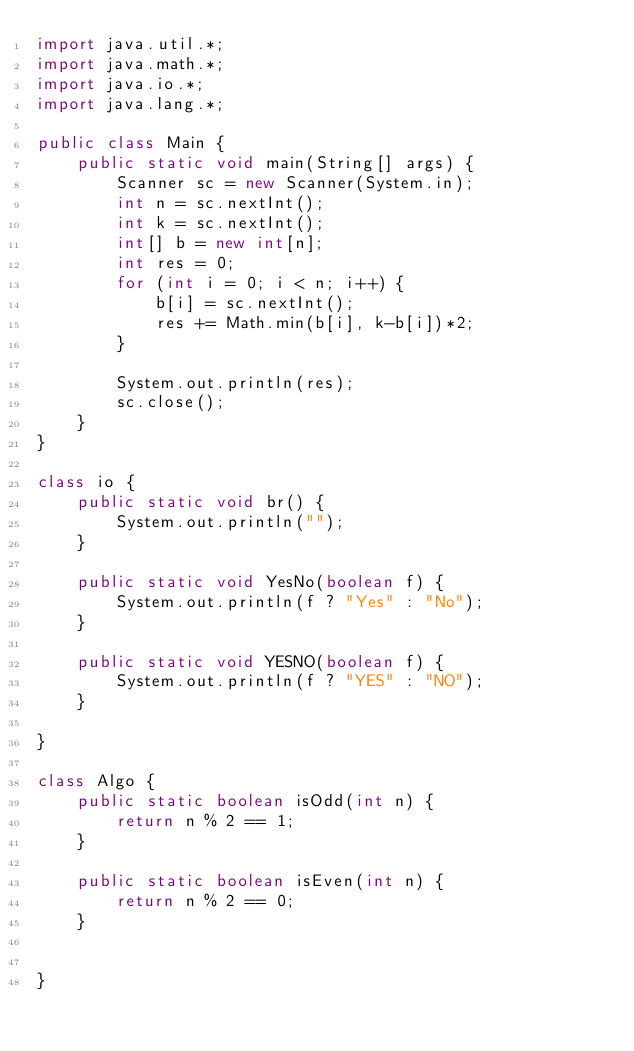<code> <loc_0><loc_0><loc_500><loc_500><_Java_>import java.util.*;
import java.math.*;
import java.io.*;
import java.lang.*;

public class Main {
    public static void main(String[] args) {
        Scanner sc = new Scanner(System.in);
        int n = sc.nextInt();
        int k = sc.nextInt();
        int[] b = new int[n];
        int res = 0;
        for (int i = 0; i < n; i++) {
            b[i] = sc.nextInt();
            res += Math.min(b[i], k-b[i])*2;
        }

        System.out.println(res);
        sc.close();
    }
}

class io {
    public static void br() {
        System.out.println("");
    }

    public static void YesNo(boolean f) {
        System.out.println(f ? "Yes" : "No");
    }

    public static void YESNO(boolean f) {
        System.out.println(f ? "YES" : "NO");
    }

}

class Algo {
    public static boolean isOdd(int n) {
        return n % 2 == 1;
    }

    public static boolean isEven(int n) {
        return n % 2 == 0;
    }


}

</code> 